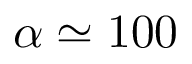Convert formula to latex. <formula><loc_0><loc_0><loc_500><loc_500>\alpha \simeq 1 0 0</formula> 